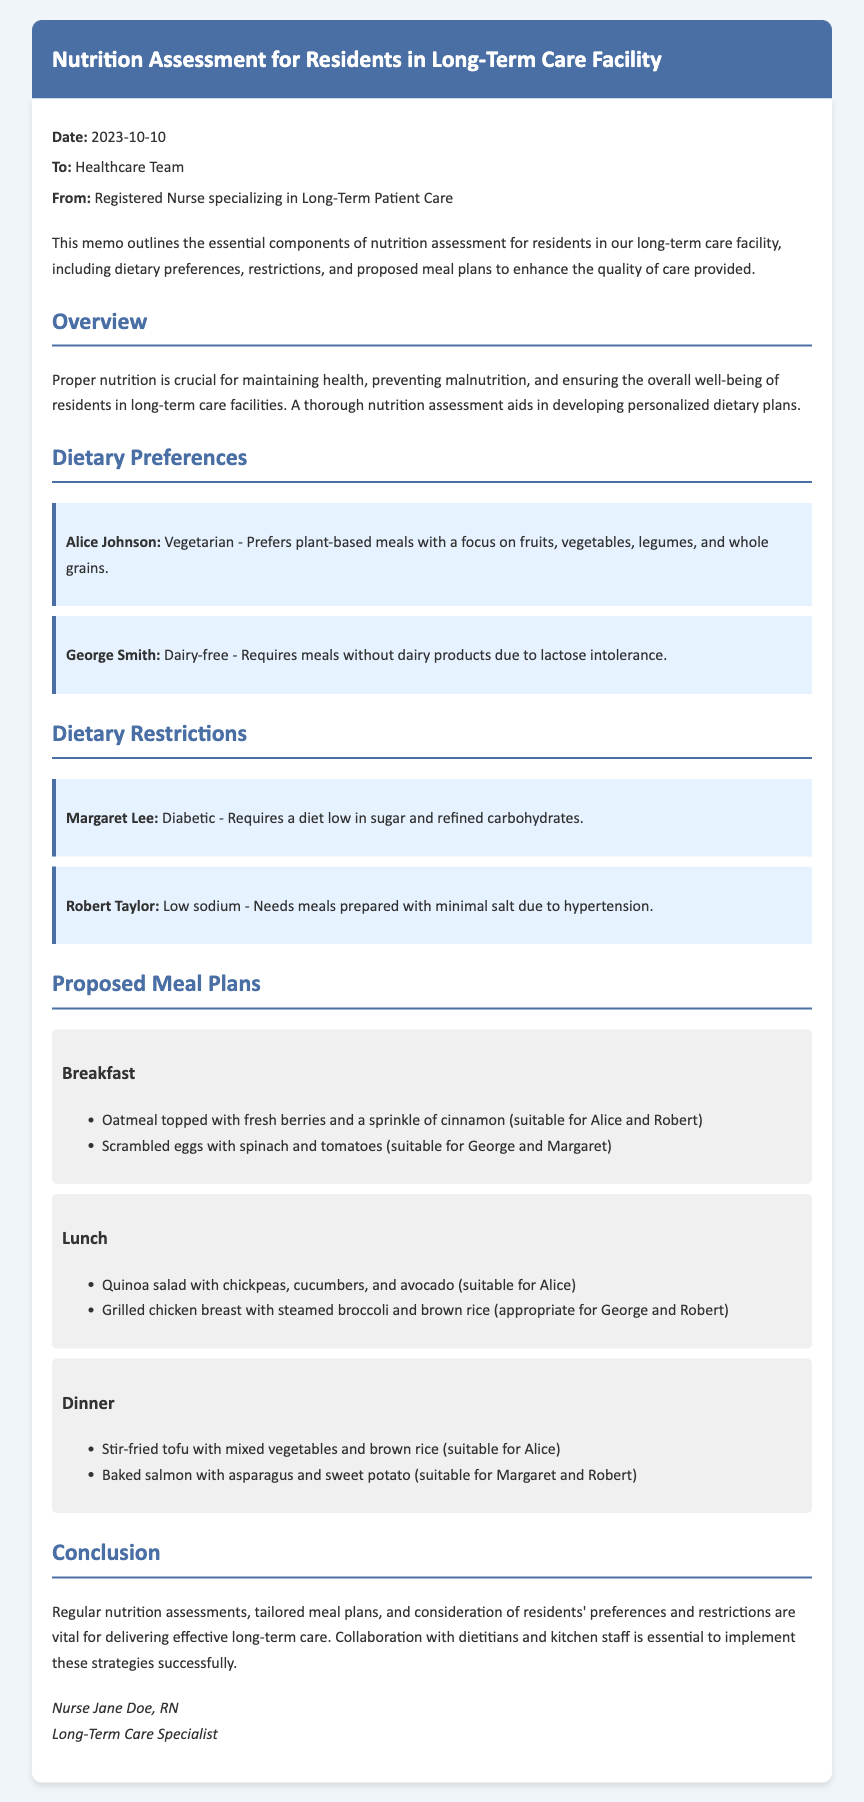What is the date of the memo? The date of the memo is explicitly mentioned in the document.
Answer: 2023-10-10 Who authored the memo? The author of the memo is specified in the conclusion section.
Answer: Registered Nurse specializing in Long-Term Patient Care Which resident is vegetarian? The dietary preference section names the vegetarian resident.
Answer: Alice Johnson What type of meal does George Smith require? George's dietary preference is noted specifically in the dietary preferences area.
Answer: Dairy-free Which resident requires a low-sugar diet? The dietary restrictions section clearly states the restriction for this resident.
Answer: Margaret Lee What is included in the breakfast plan for Alice? The meal plan section details specific breakfast options.
Answer: Oatmeal topped with fresh berries and a sprinkle of cinnamon What is the main protein in the dinner option for Margaret? The proposed meal plans list suitable dinner meals including proteins.
Answer: Baked salmon Which meal includes quinoa salad? The lunch meal plan explicitly mentions the dish.
Answer: Lunch Who needs low sodium meals? The dietary restrictions section indicates the resident with this need.
Answer: Robert Taylor 